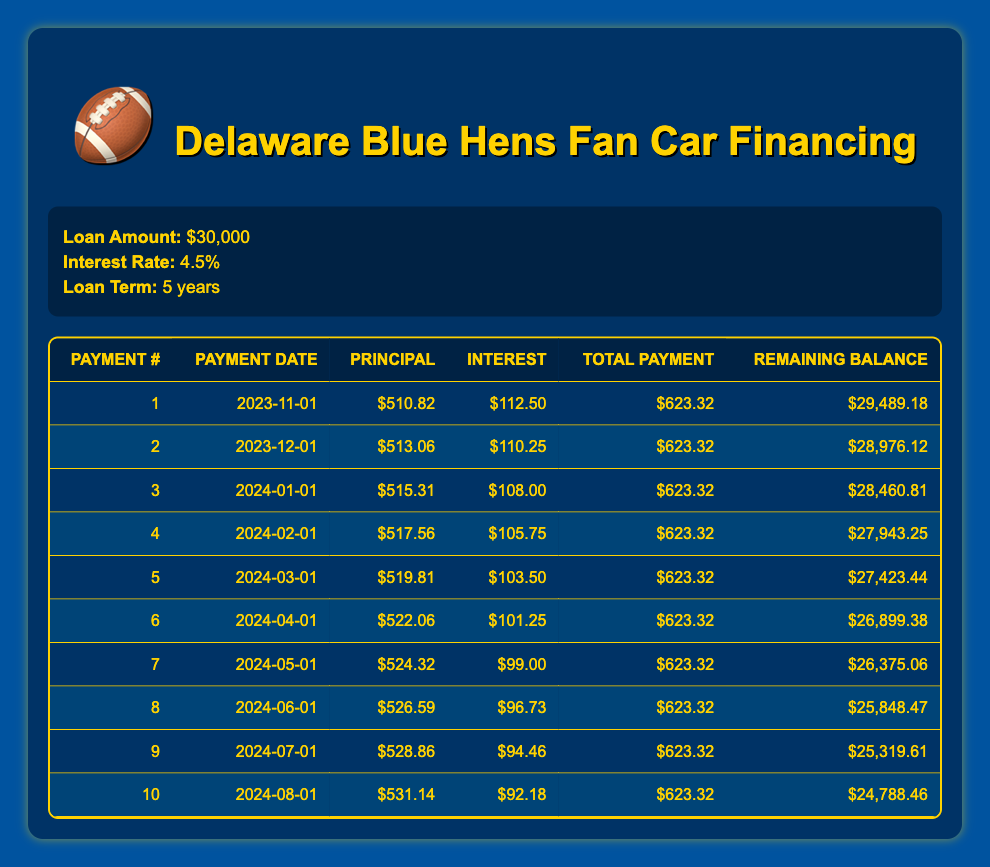What is the total payment amount for the first month? In the first row of the table, under "Total Payment," the amount listed is $623.32 for the first payment.
Answer: $623.32 How much of the fifth payment goes towards the principal? In the fifth row of the table, under "Principal," the amount that goes towards the principal payment is $519.81.
Answer: $519.81 What is the total interest paid by the second month? To find this, we add the interest payments from the first two months: $112.50 (first month) + $110.25 (second month) = $222.75.
Answer: $222.75 Is the total payment amount consistent every month? Every monthly payment listed in the "Total Payment" column shows a consistent amount of $623.32, confirming the consistency.
Answer: Yes What is the remaining balance after the fourth payment? In the fourth row, the "Remaining Balance" is $27,943.25, indicating the balance after the fourth payment has been made.
Answer: $27,943.25 How much less interest is paid in the third payment compared to the first payment? The interest for the first payment is $112.50, and for the third payment, it is $108.00. The difference is $112.50 - $108.00 = $4.50 less interest paid.
Answer: $4.50 What is the average monthly principal payment over the first ten payments? Adding all the principal payments from the first ten rows gives a total of $5,179.79. Dividing this by 10 (the number of payments) results in an average principal payment of $517.98.
Answer: $517.98 How much is the remaining balance reduced after the sixth payment? Comparing the remaining balance before the sixth month ($27,423.44 after the fifth payment) to after the sixth payment ($26,899.38), the balance decreased by $524.06 ($27,423.44 - $26,899.38).
Answer: $524.06 What trend can you see in the interest payments over the first ten months? The interest payments decrease with each subsequent payment: the first payment has $112.50, and the tenth payment has $92.18, showing a decreasing trend.
Answer: Decreasing trend 